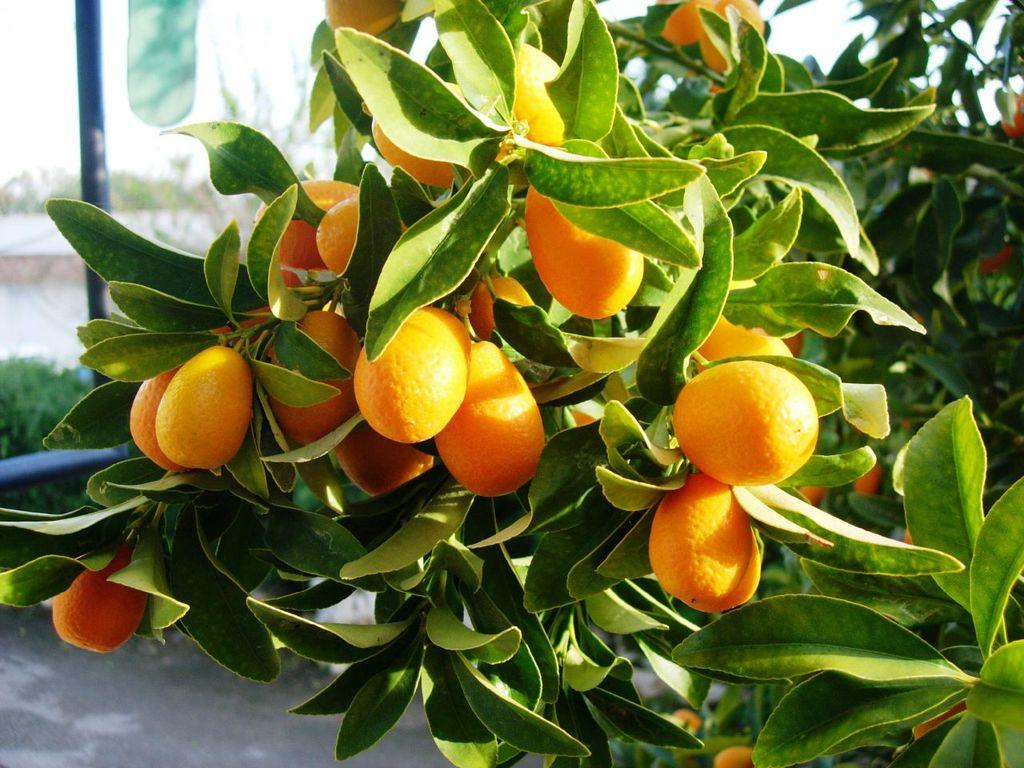What type of plant is visible in the image? There is a plant with oranges in the image. What can be seen at the bottom of the image? There is a road at the bottom of the image. Can you describe the background of the image? The background of the image is blurred. What type of cloud can be seen on the canvas in the image? There is no canvas or cloud present in the image. 